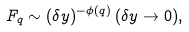<formula> <loc_0><loc_0><loc_500><loc_500>F _ { q } \sim ( \delta y ) ^ { - \phi ( q ) } \, ( \delta y \rightarrow 0 ) ,</formula> 